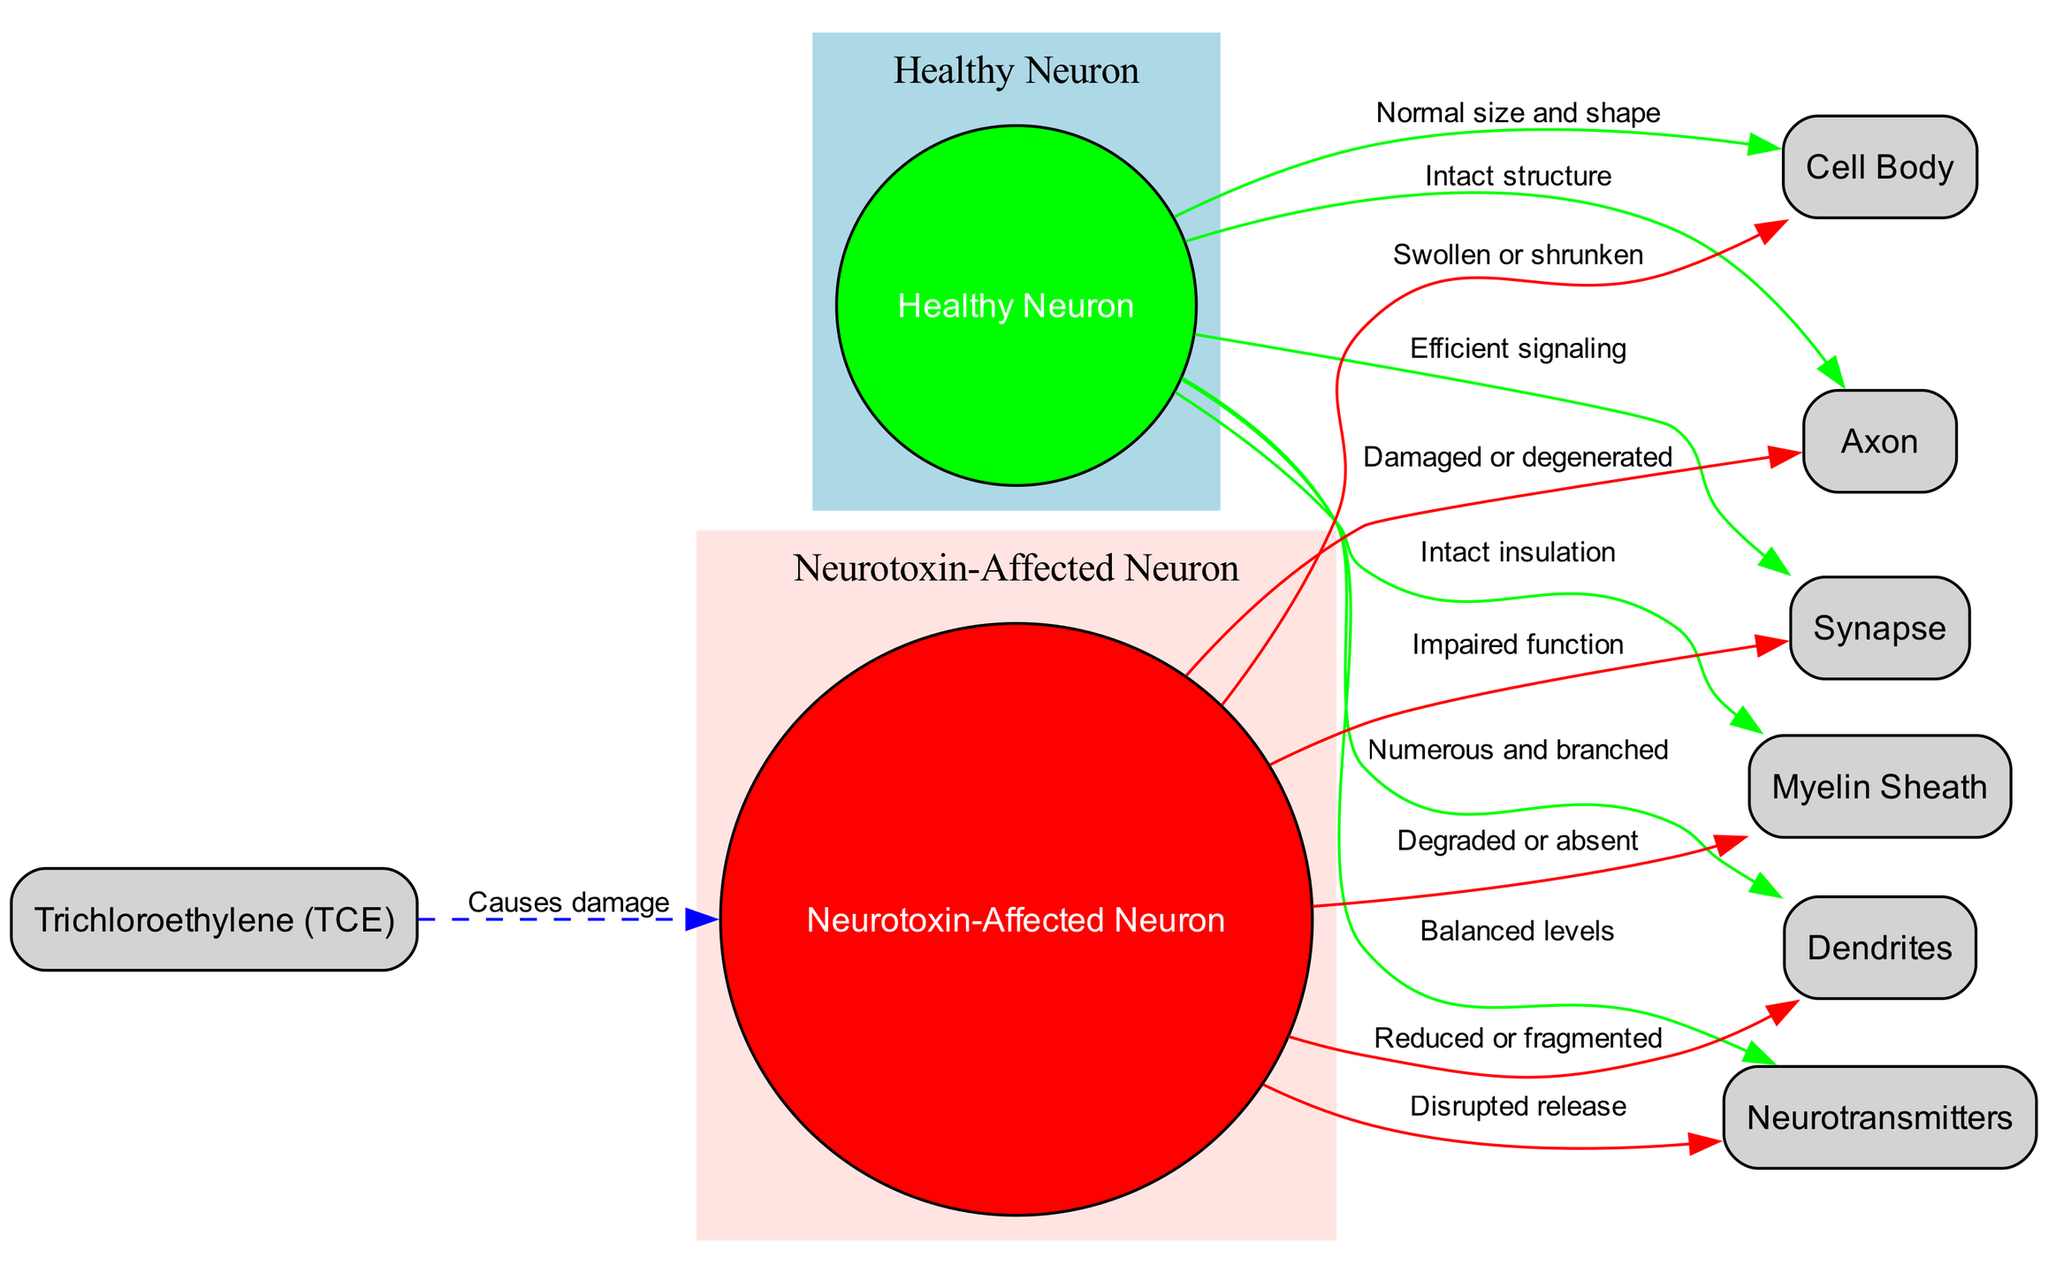What is the label for the "cell body" of a healthy neuron? The diagram specifies that the cell body of a healthy neuron has the label "Normal size and shape." Therefore, the label indicates that the cell body maintains its regular structure.
Answer: Normal size and shape What is the condition of the axon in the neurotoxin-affected neuron? According to the diagram, the axon of the neurotoxin-affected neuron is described as "Damaged or degenerated." This indicates that the neurotoxin has caused structural harm to the axon.
Answer: Damaged or degenerated How many nodes are there in the diagram? The diagram features a total of eight nodes, including both healthy and affected neurons, along with components like the cell body, axon, dendrites, myelin sheath, synapse, neurotransmitters, and trichloroethylene.
Answer: Eight What does trichloroethylene do to affected neurons? The diagram indicates that trichloroethylene "Causes damage" to the affected neuron. This suggests a direct harmful impact from the substance on neuronal health.
Answer: Causes damage How do the neurotransmitter levels differ between healthy and affected neurons? The healthy neuron is characterized by "Balanced levels" of neurotransmitters, whereas the affected neuron experiences "Disrupted release." This comparison shows a fundamental difference in neurotransmitter functionality due to neurotoxin impact.
Answer: Disrupted release What is the appearance of dendrites in a healthy neuron? The diagram specifies that the dendrites in a healthy neuron are characterized as "Numerous and branched," indicating a healthy structure conducive to effective communication.
Answer: Numerous and branched What is the state of the myelin sheath in a neurotoxin-affected neuron? The myelin sheath in the neurotoxin-affected neuron is indicated to be "Degraded or absent," highlighting significant damage that affects neuronal transmission.
Answer: Degraded or absent What is the effect of neurotoxins on synaptic function in affected neurons? The synapse in neurotoxin-affected neurons is described as having "Impaired function," which implies that the signaling process between neurons is negatively affected due to toxicity.
Answer: Impaired function 